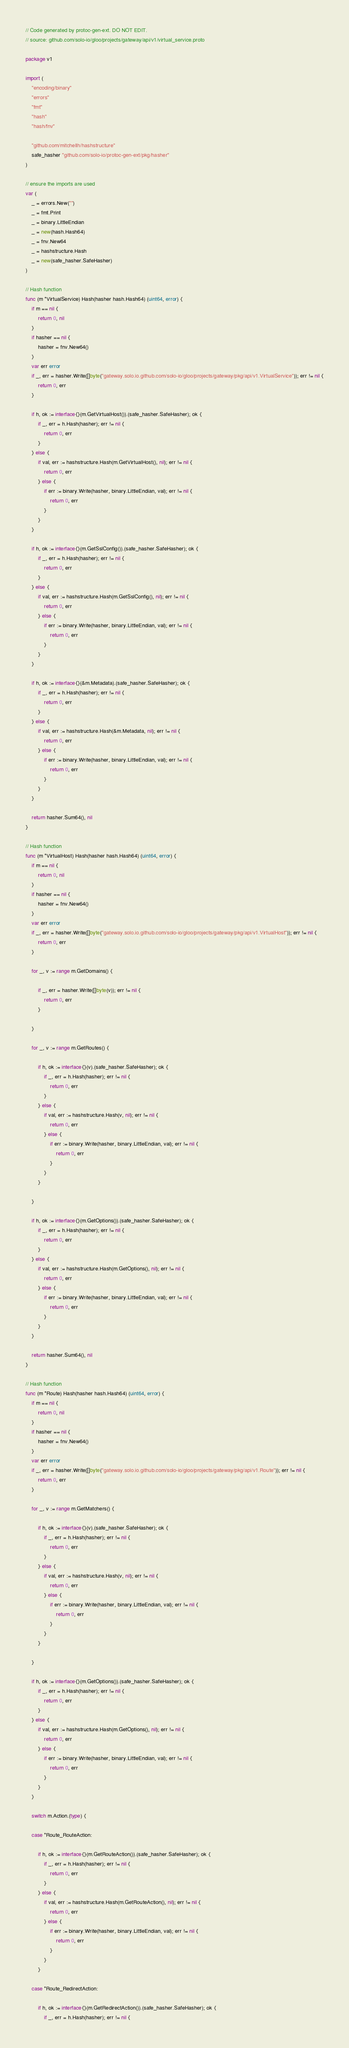<code> <loc_0><loc_0><loc_500><loc_500><_Go_>// Code generated by protoc-gen-ext. DO NOT EDIT.
// source: github.com/solo-io/gloo/projects/gateway/api/v1/virtual_service.proto

package v1

import (
	"encoding/binary"
	"errors"
	"fmt"
	"hash"
	"hash/fnv"

	"github.com/mitchellh/hashstructure"
	safe_hasher "github.com/solo-io/protoc-gen-ext/pkg/hasher"
)

// ensure the imports are used
var (
	_ = errors.New("")
	_ = fmt.Print
	_ = binary.LittleEndian
	_ = new(hash.Hash64)
	_ = fnv.New64
	_ = hashstructure.Hash
	_ = new(safe_hasher.SafeHasher)
)

// Hash function
func (m *VirtualService) Hash(hasher hash.Hash64) (uint64, error) {
	if m == nil {
		return 0, nil
	}
	if hasher == nil {
		hasher = fnv.New64()
	}
	var err error
	if _, err = hasher.Write([]byte("gateway.solo.io.github.com/solo-io/gloo/projects/gateway/pkg/api/v1.VirtualService")); err != nil {
		return 0, err
	}

	if h, ok := interface{}(m.GetVirtualHost()).(safe_hasher.SafeHasher); ok {
		if _, err = h.Hash(hasher); err != nil {
			return 0, err
		}
	} else {
		if val, err := hashstructure.Hash(m.GetVirtualHost(), nil); err != nil {
			return 0, err
		} else {
			if err := binary.Write(hasher, binary.LittleEndian, val); err != nil {
				return 0, err
			}
		}
	}

	if h, ok := interface{}(m.GetSslConfig()).(safe_hasher.SafeHasher); ok {
		if _, err = h.Hash(hasher); err != nil {
			return 0, err
		}
	} else {
		if val, err := hashstructure.Hash(m.GetSslConfig(), nil); err != nil {
			return 0, err
		} else {
			if err := binary.Write(hasher, binary.LittleEndian, val); err != nil {
				return 0, err
			}
		}
	}

	if h, ok := interface{}(&m.Metadata).(safe_hasher.SafeHasher); ok {
		if _, err = h.Hash(hasher); err != nil {
			return 0, err
		}
	} else {
		if val, err := hashstructure.Hash(&m.Metadata, nil); err != nil {
			return 0, err
		} else {
			if err := binary.Write(hasher, binary.LittleEndian, val); err != nil {
				return 0, err
			}
		}
	}

	return hasher.Sum64(), nil
}

// Hash function
func (m *VirtualHost) Hash(hasher hash.Hash64) (uint64, error) {
	if m == nil {
		return 0, nil
	}
	if hasher == nil {
		hasher = fnv.New64()
	}
	var err error
	if _, err = hasher.Write([]byte("gateway.solo.io.github.com/solo-io/gloo/projects/gateway/pkg/api/v1.VirtualHost")); err != nil {
		return 0, err
	}

	for _, v := range m.GetDomains() {

		if _, err = hasher.Write([]byte(v)); err != nil {
			return 0, err
		}

	}

	for _, v := range m.GetRoutes() {

		if h, ok := interface{}(v).(safe_hasher.SafeHasher); ok {
			if _, err = h.Hash(hasher); err != nil {
				return 0, err
			}
		} else {
			if val, err := hashstructure.Hash(v, nil); err != nil {
				return 0, err
			} else {
				if err := binary.Write(hasher, binary.LittleEndian, val); err != nil {
					return 0, err
				}
			}
		}

	}

	if h, ok := interface{}(m.GetOptions()).(safe_hasher.SafeHasher); ok {
		if _, err = h.Hash(hasher); err != nil {
			return 0, err
		}
	} else {
		if val, err := hashstructure.Hash(m.GetOptions(), nil); err != nil {
			return 0, err
		} else {
			if err := binary.Write(hasher, binary.LittleEndian, val); err != nil {
				return 0, err
			}
		}
	}

	return hasher.Sum64(), nil
}

// Hash function
func (m *Route) Hash(hasher hash.Hash64) (uint64, error) {
	if m == nil {
		return 0, nil
	}
	if hasher == nil {
		hasher = fnv.New64()
	}
	var err error
	if _, err = hasher.Write([]byte("gateway.solo.io.github.com/solo-io/gloo/projects/gateway/pkg/api/v1.Route")); err != nil {
		return 0, err
	}

	for _, v := range m.GetMatchers() {

		if h, ok := interface{}(v).(safe_hasher.SafeHasher); ok {
			if _, err = h.Hash(hasher); err != nil {
				return 0, err
			}
		} else {
			if val, err := hashstructure.Hash(v, nil); err != nil {
				return 0, err
			} else {
				if err := binary.Write(hasher, binary.LittleEndian, val); err != nil {
					return 0, err
				}
			}
		}

	}

	if h, ok := interface{}(m.GetOptions()).(safe_hasher.SafeHasher); ok {
		if _, err = h.Hash(hasher); err != nil {
			return 0, err
		}
	} else {
		if val, err := hashstructure.Hash(m.GetOptions(), nil); err != nil {
			return 0, err
		} else {
			if err := binary.Write(hasher, binary.LittleEndian, val); err != nil {
				return 0, err
			}
		}
	}

	switch m.Action.(type) {

	case *Route_RouteAction:

		if h, ok := interface{}(m.GetRouteAction()).(safe_hasher.SafeHasher); ok {
			if _, err = h.Hash(hasher); err != nil {
				return 0, err
			}
		} else {
			if val, err := hashstructure.Hash(m.GetRouteAction(), nil); err != nil {
				return 0, err
			} else {
				if err := binary.Write(hasher, binary.LittleEndian, val); err != nil {
					return 0, err
				}
			}
		}

	case *Route_RedirectAction:

		if h, ok := interface{}(m.GetRedirectAction()).(safe_hasher.SafeHasher); ok {
			if _, err = h.Hash(hasher); err != nil {</code> 